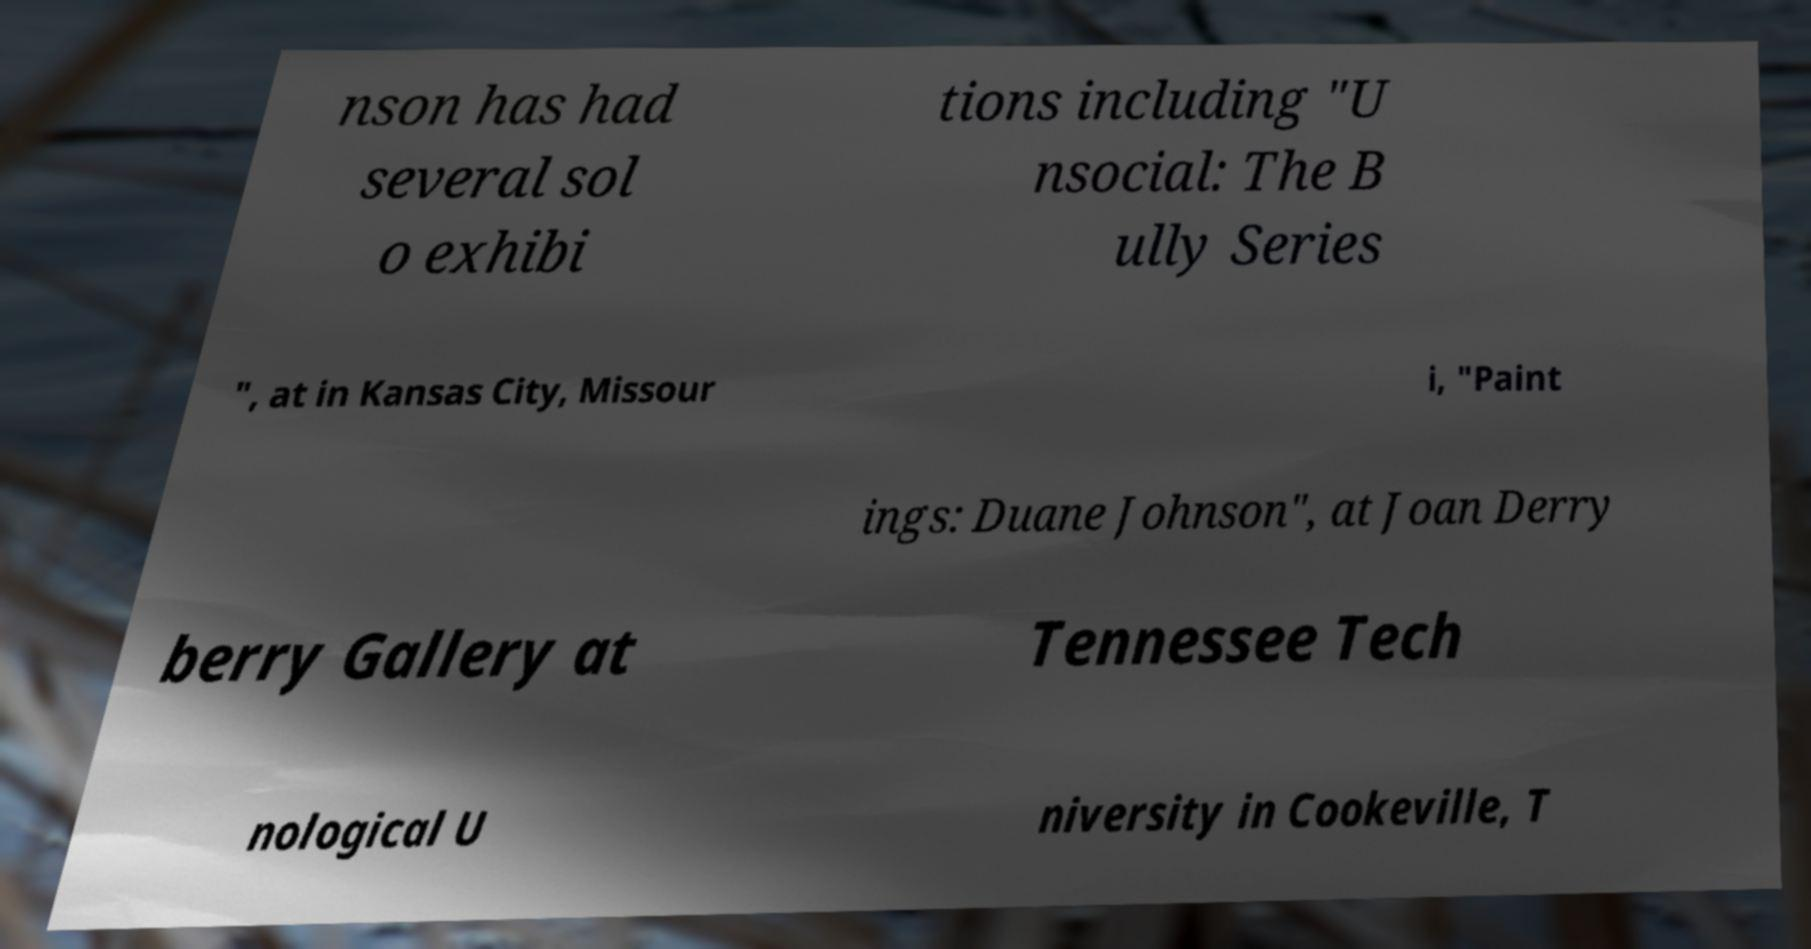For documentation purposes, I need the text within this image transcribed. Could you provide that? nson has had several sol o exhibi tions including "U nsocial: The B ully Series ", at in Kansas City, Missour i, "Paint ings: Duane Johnson", at Joan Derry berry Gallery at Tennessee Tech nological U niversity in Cookeville, T 